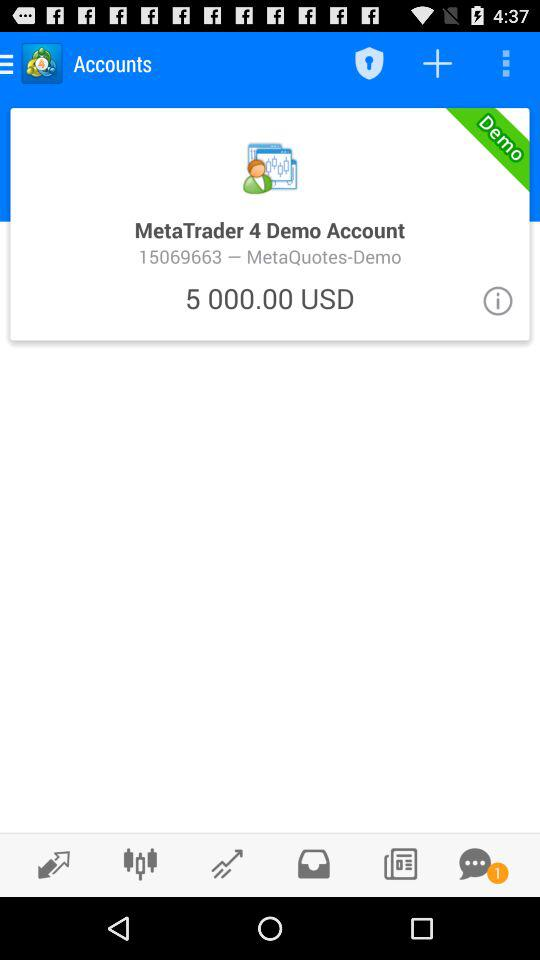What is the amount in the "MetaTrader 4" demo account? The amount is 5,000.00 USD. 